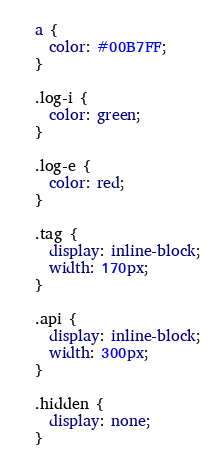Convert code to text. <code><loc_0><loc_0><loc_500><loc_500><_CSS_>a {
  color: #00B7FF;
}

.log-i {
  color: green;
}

.log-e {
  color: red;
}

.tag {
  display: inline-block;
  width: 170px;
}

.api {
  display: inline-block;
  width: 300px;
}

.hidden {
  display: none;
}</code> 